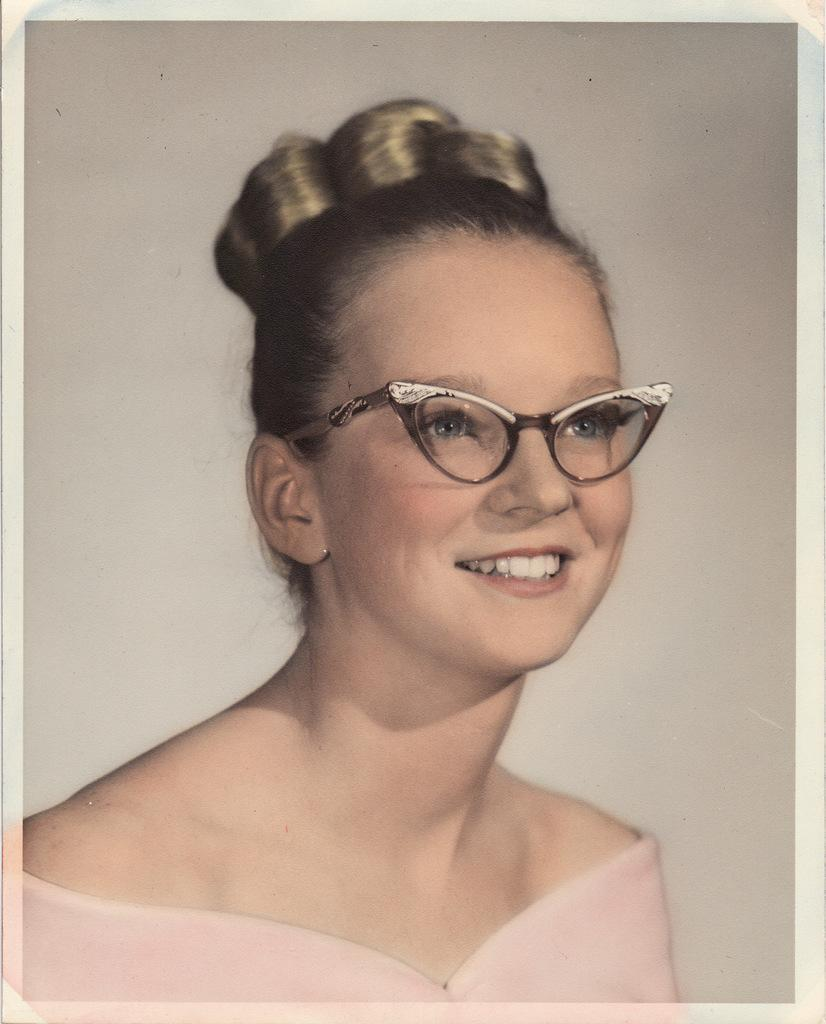Who is present in the image? There is a woman in the image. What expression does the woman have? The woman is smiling. What is visible behind the woman? There is a wall behind the woman. What type of texture can be seen on the fireman's uniform in the image? There is no fireman or uniform present in the image; it features a woman smiling with a wall behind her. 